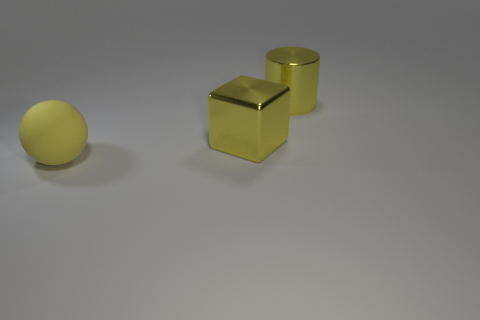Add 3 large yellow metal objects. How many objects exist? 6 Subtract all spheres. How many objects are left? 2 Add 1 yellow cubes. How many yellow cubes are left? 2 Add 2 large cyan matte balls. How many large cyan matte balls exist? 2 Subtract 0 blue cubes. How many objects are left? 3 Subtract all tiny purple spheres. Subtract all large things. How many objects are left? 0 